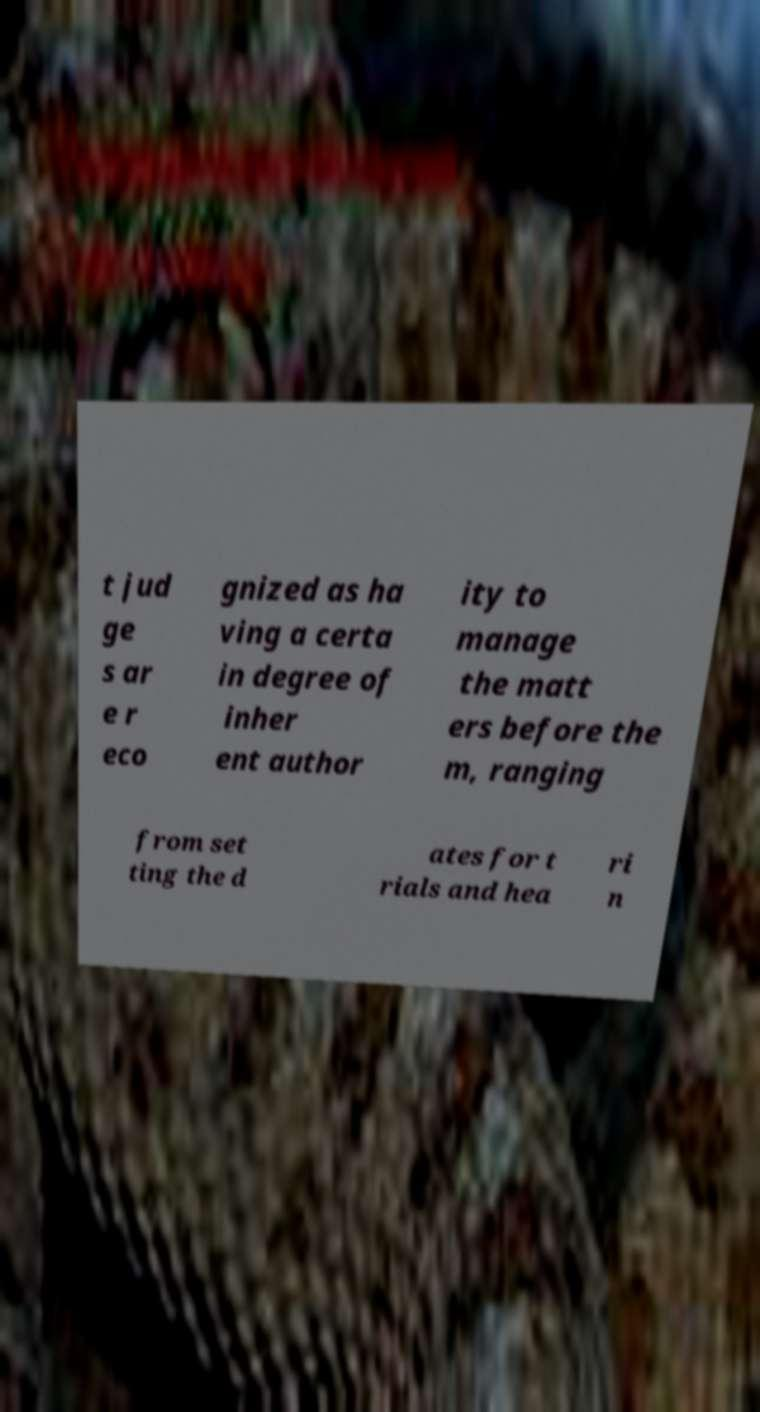Can you accurately transcribe the text from the provided image for me? t jud ge s ar e r eco gnized as ha ving a certa in degree of inher ent author ity to manage the matt ers before the m, ranging from set ting the d ates for t rials and hea ri n 